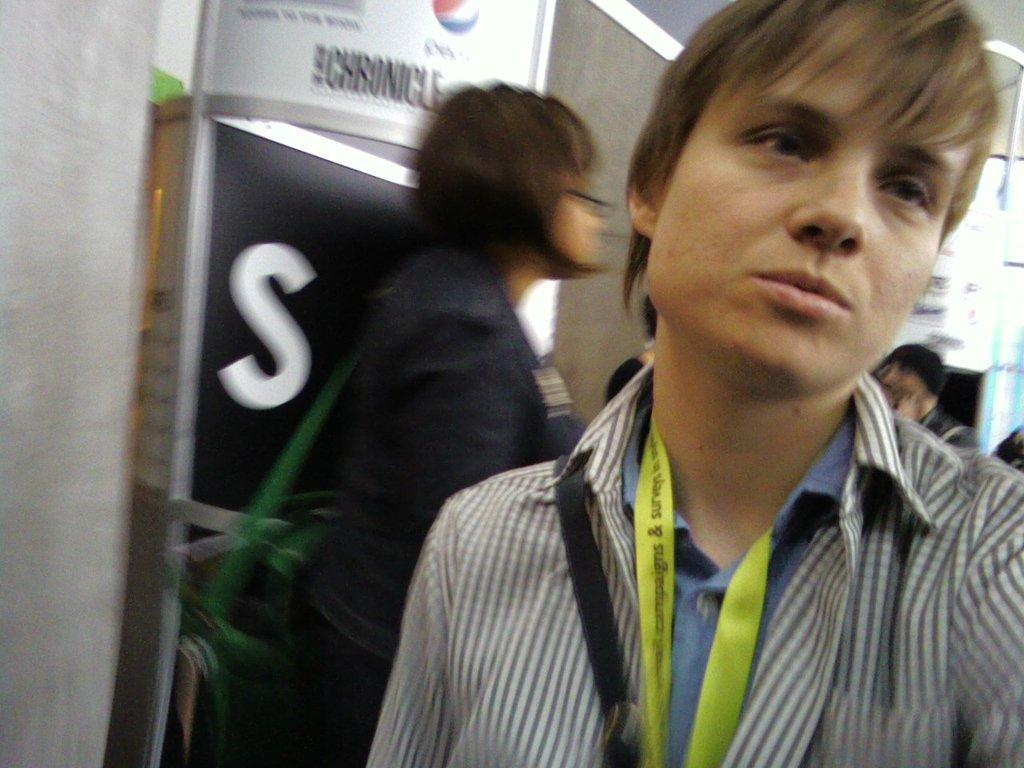What is the person in the foreground wearing in the image? The person in the foreground is wearing a black and white shirt. What color tag is the person wearing? The person is wearing a green color tag. Can you describe the person in the background? There is a person in the background wearing a black dress. What can be seen in the background of the image? There is a white color board visible in the background. What type of cherries are being used to decorate the car in the image? There is no car or cherries present in the image. 